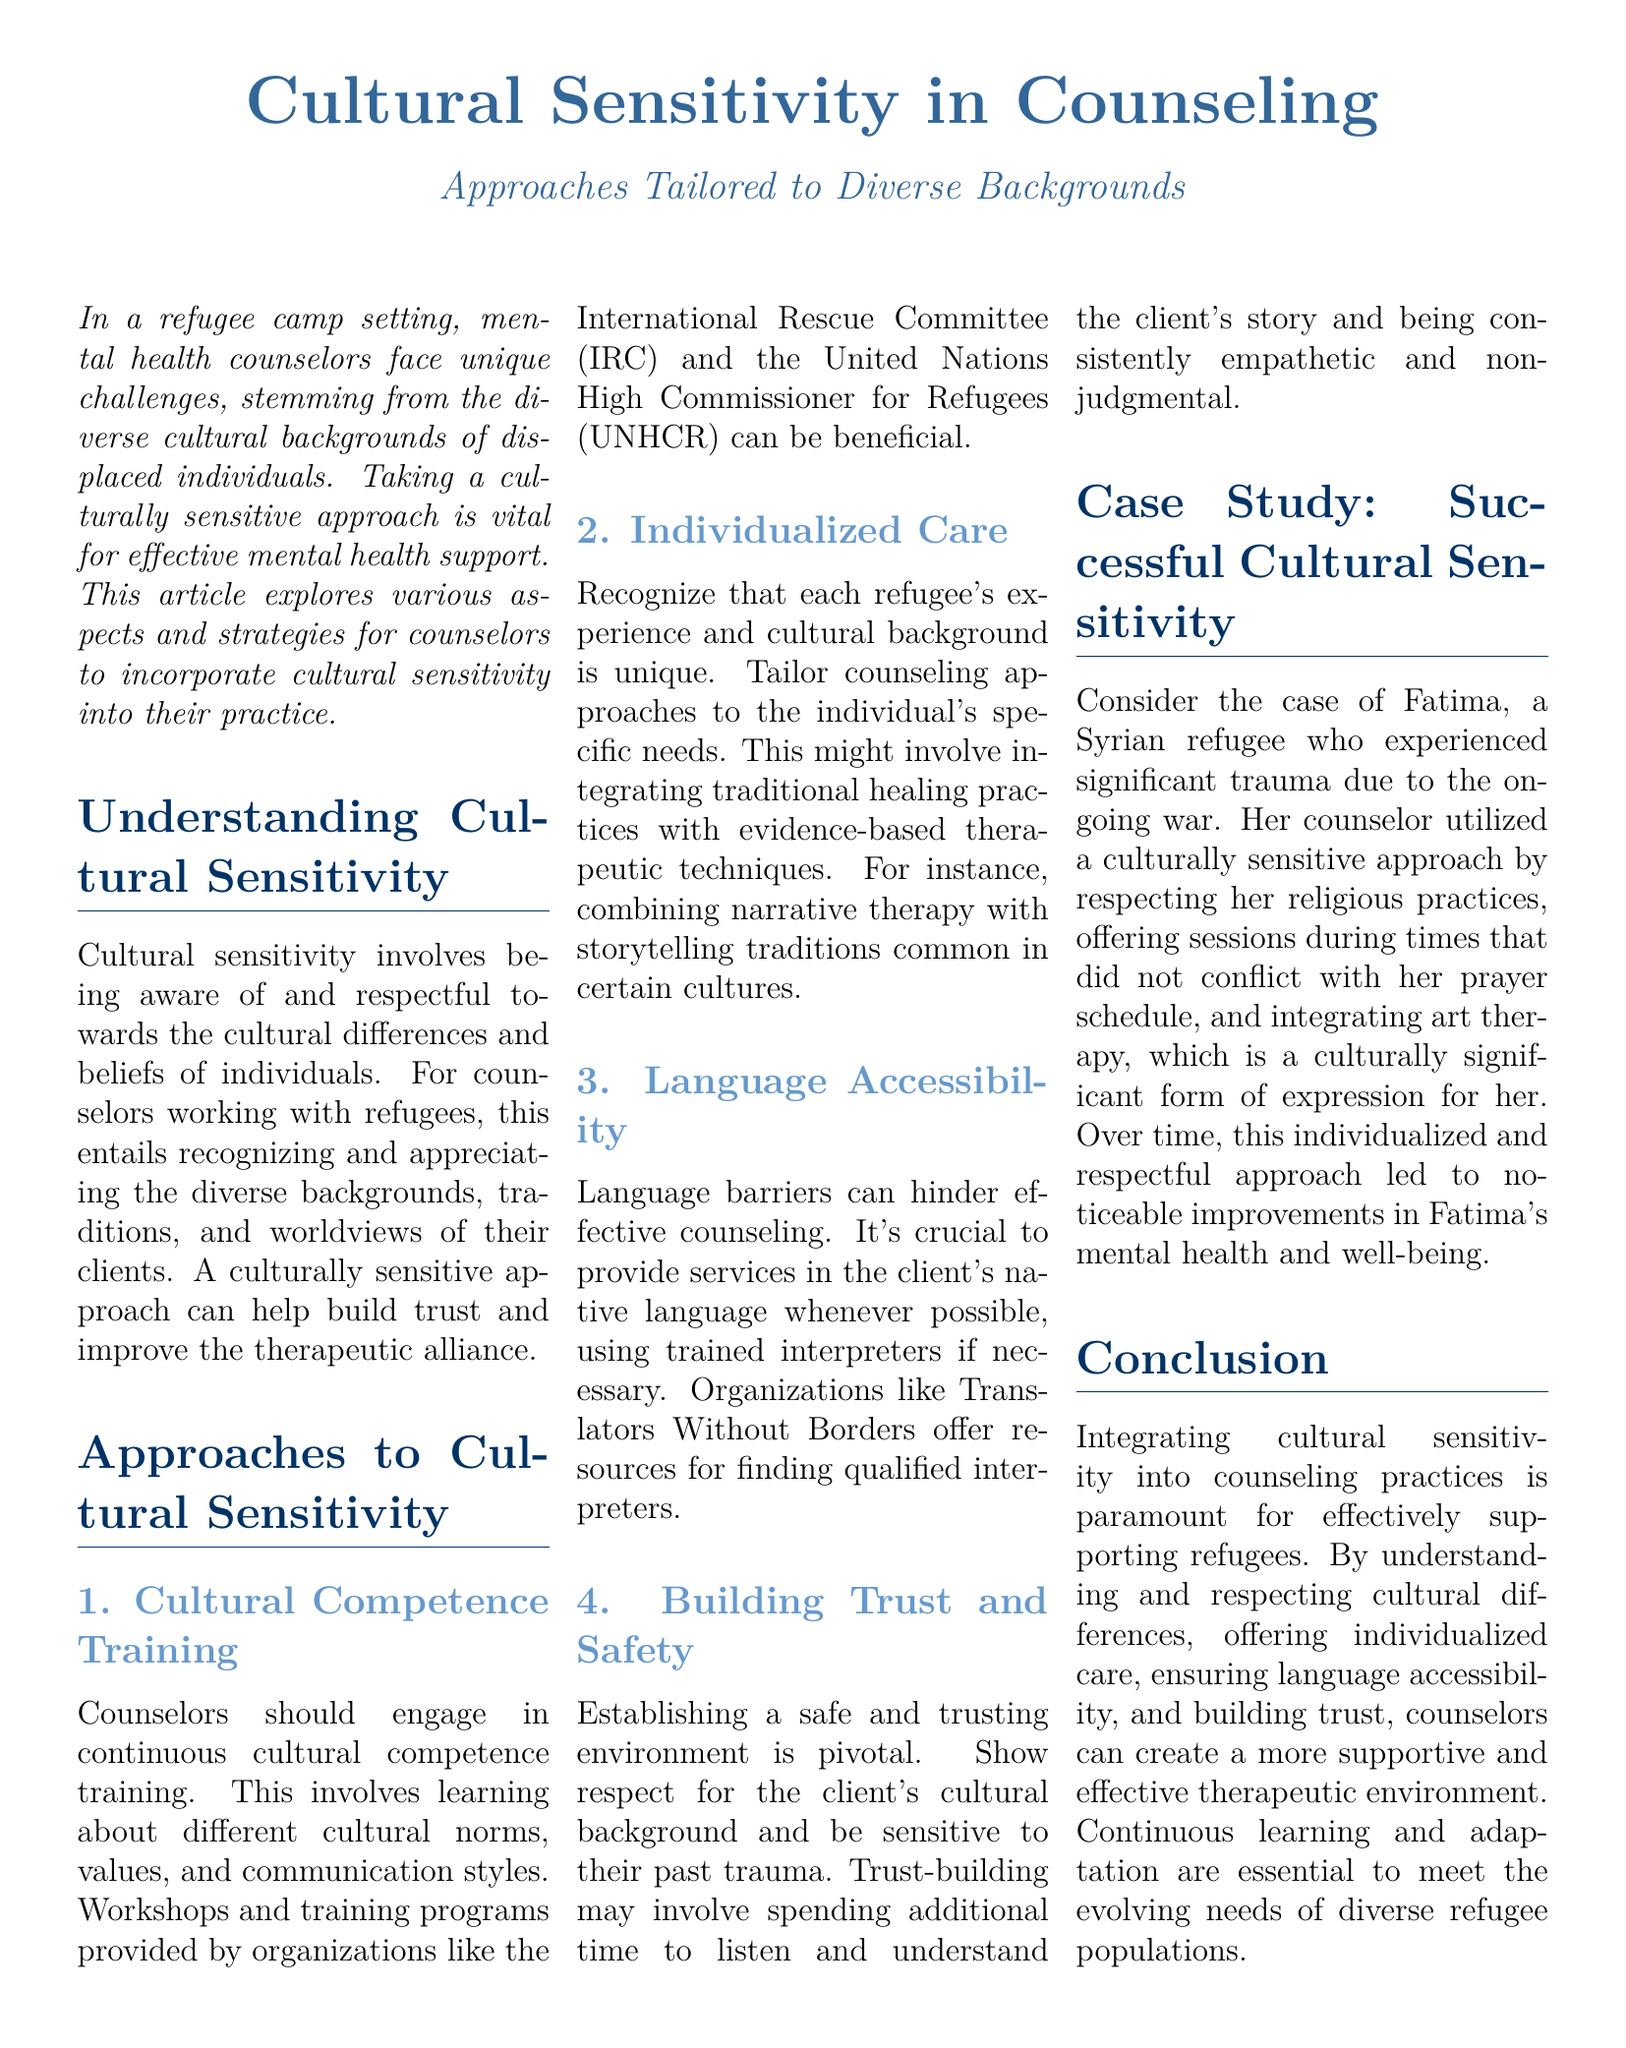What is the main topic of the document? The main topic is outlined in the title, focusing on the importance of cultural sensitivity in counseling for refugees.
Answer: Cultural Sensitivity in Counseling What organizations are mentioned for cultural competence training? The document mentions two organizations that provide helpful training programs for counselors.
Answer: International Rescue Committee and United Nations High Commissioner for Refugees What type of therapy was incorporated with Fatima’s counseling? The document describes a particular therapeutic approach that was significant for Fatima, reflecting her cultural background.
Answer: Art therapy What is a key aspect of establishing a counseling environment with refugees? The document highlights the importance of an interpersonal dynamic between counselors and clients, particularly in sensitive contexts.
Answer: Trust What specific resource is mentioned for overcoming language barriers? The document suggests a particular organization that offers assistance with language issues in counseling sessions.
Answer: Translators Without Borders How can counselors tailor their approaches according to clients' needs? This question addresses the customization aspect of counseling practices highlighted in the document.
Answer: Individualized Care What role does trauma play in the counseling process outlined? This question seeks to understand the overarching impact that previous experiences have on the counseling relationship.
Answer: Past trauma What is the purpose of cultural competence training? The document provides insight into the rationale behind continuous professional development in a culturally diverse context.
Answer: Learning about different cultural norms and values 